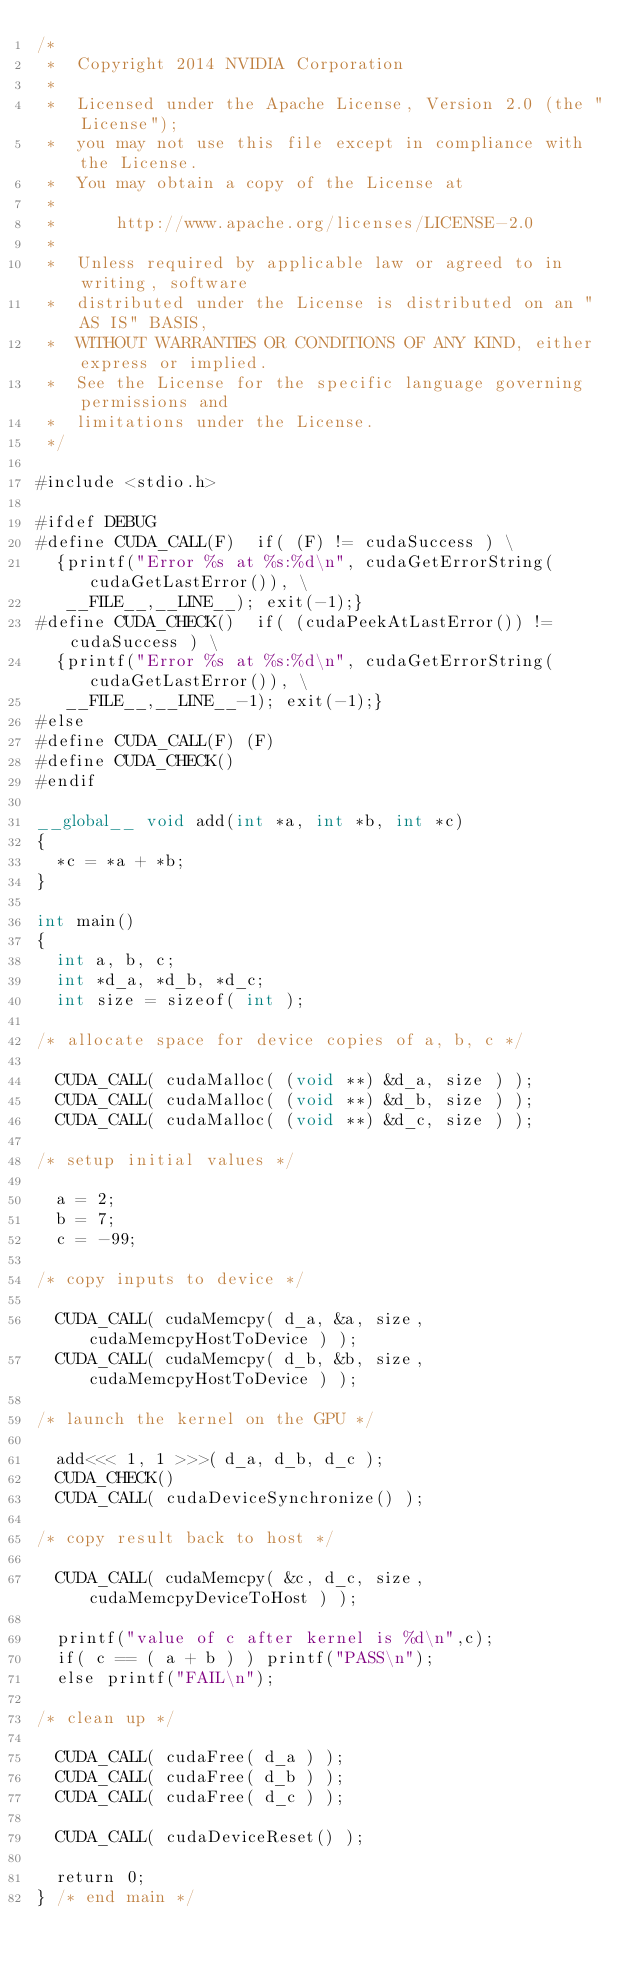Convert code to text. <code><loc_0><loc_0><loc_500><loc_500><_Cuda_>/*
 *  Copyright 2014 NVIDIA Corporation
 *
 *  Licensed under the Apache License, Version 2.0 (the "License");
 *  you may not use this file except in compliance with the License.
 *  You may obtain a copy of the License at
 *
 *      http://www.apache.org/licenses/LICENSE-2.0
 *
 *  Unless required by applicable law or agreed to in writing, software
 *  distributed under the License is distributed on an "AS IS" BASIS,
 *  WITHOUT WARRANTIES OR CONDITIONS OF ANY KIND, either express or implied.
 *  See the License for the specific language governing permissions and
 *  limitations under the License.
 */

#include <stdio.h>

#ifdef DEBUG
#define CUDA_CALL(F)  if( (F) != cudaSuccess ) \
  {printf("Error %s at %s:%d\n", cudaGetErrorString(cudaGetLastError()), \
   __FILE__,__LINE__); exit(-1);} 
#define CUDA_CHECK()  if( (cudaPeekAtLastError()) != cudaSuccess ) \
  {printf("Error %s at %s:%d\n", cudaGetErrorString(cudaGetLastError()), \
   __FILE__,__LINE__-1); exit(-1);} 
#else
#define CUDA_CALL(F) (F)
#define CUDA_CHECK() 
#endif

__global__ void add(int *a, int *b, int *c)
{
  *c = *a + *b;
}

int main()
{
  int a, b, c;
  int *d_a, *d_b, *d_c;
  int size = sizeof( int );

/* allocate space for device copies of a, b, c */

  CUDA_CALL( cudaMalloc( (void **) &d_a, size ) );
  CUDA_CALL( cudaMalloc( (void **) &d_b, size ) );
  CUDA_CALL( cudaMalloc( (void **) &d_c, size ) );

/* setup initial values */

  a = 2;
  b = 7;
  c = -99;

/* copy inputs to device */

  CUDA_CALL( cudaMemcpy( d_a, &a, size, cudaMemcpyHostToDevice ) );
  CUDA_CALL( cudaMemcpy( d_b, &b, size, cudaMemcpyHostToDevice ) );

/* launch the kernel on the GPU */

  add<<< 1, 1 >>>( d_a, d_b, d_c );
  CUDA_CHECK()
  CUDA_CALL( cudaDeviceSynchronize() );

/* copy result back to host */

  CUDA_CALL( cudaMemcpy( &c, d_c, size, cudaMemcpyDeviceToHost ) );

  printf("value of c after kernel is %d\n",c);
  if( c == ( a + b ) ) printf("PASS\n");
  else printf("FAIL\n");

/* clean up */

  CUDA_CALL( cudaFree( d_a ) );
  CUDA_CALL( cudaFree( d_b ) );
  CUDA_CALL( cudaFree( d_c ) );

  CUDA_CALL( cudaDeviceReset() );
	
  return 0;
} /* end main */
</code> 